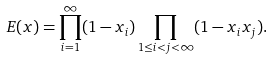Convert formula to latex. <formula><loc_0><loc_0><loc_500><loc_500>E ( x ) = \prod _ { i = 1 } ^ { \infty } ( 1 - x _ { i } ) \prod _ { 1 \leq i < j < \infty } ( 1 - x _ { i } x _ { j } ) .</formula> 